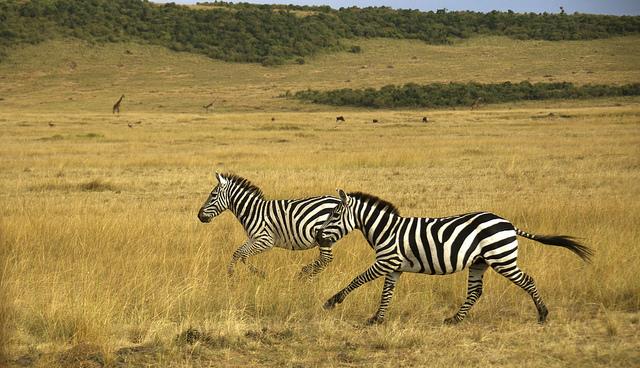Is the terrain flat?
Answer briefly. Yes. Are these zebras running?
Keep it brief. Yes. Are there animals in the background?
Write a very short answer. Yes. How many animals are depicted?
Concise answer only. 2. What continent are these animals from?
Quick response, please. Africa. 